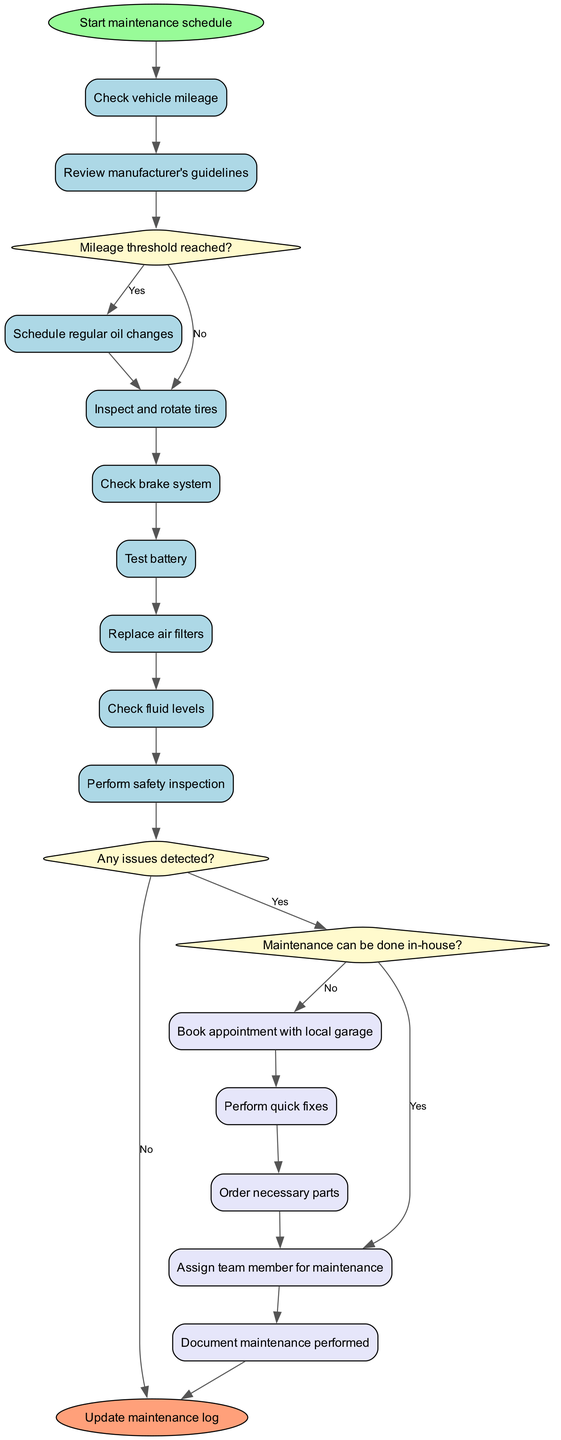What is the first activity in the maintenance schedule? The diagram shows the flow starts from the initial node, which leads to the first activity, that is "Check vehicle mileage".
Answer: Check vehicle mileage How many decisions are present in the diagram? By reviewing the diagram, we can count that there are three decision nodes labeled "Mileage threshold reached?", "Any issues detected?", and "Maintenance can be done in-house?"
Answer: 3 What follows the activity "Inspect and rotate tires"? The activity "Inspect and rotate tires" is followed by the activity "Check brake system", as indicated by the directed edges connecting these nodes in the flow of the diagram.
Answer: Check brake system If a maintenance issue is detected, what is the next decision in the process? If any issues are detected in the maintenance process at the decision node "Any issues detected?", the next action leads to the decision node "Maintenance can be done in-house?", as shown by the directed flow from the second decision node.
Answer: Maintenance can be done in-house? What action occurs after ordering necessary parts? The action "Order necessary parts" is followed by "Assign team member for maintenance", indicating that once parts are ordered, the next step involves assigning someone to handle the maintenance tasks.
Answer: Assign team member for maintenance What is the final output of the maintenance schedule process? The final node in the activity diagram confirms that the last step in the process is to "Update maintenance log", signifying the conclusion of all activities undertaken during maintenance.
Answer: Update maintenance log Which activity is performed before checking fluid levels? The activity "Replace air filters" occurs immediately before "Check fluid levels", according to the flow from the previous activity node to the next.
Answer: Replace air filters What does the diagram indicate if the mileage threshold is not reached? If the mileage threshold is not reached at the decision node "Mileage threshold reached?", the flow shows that the process continues directly to the activity "Inspect and rotate tires", indicating that no oil change is scheduled at that moment.
Answer: Inspect and rotate tires 